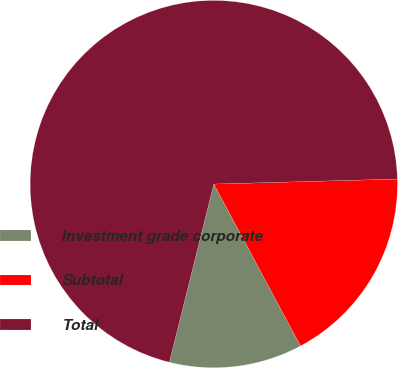Convert chart. <chart><loc_0><loc_0><loc_500><loc_500><pie_chart><fcel>Investment grade corporate<fcel>Subtotal<fcel>Total<nl><fcel>11.71%<fcel>17.61%<fcel>70.68%<nl></chart> 